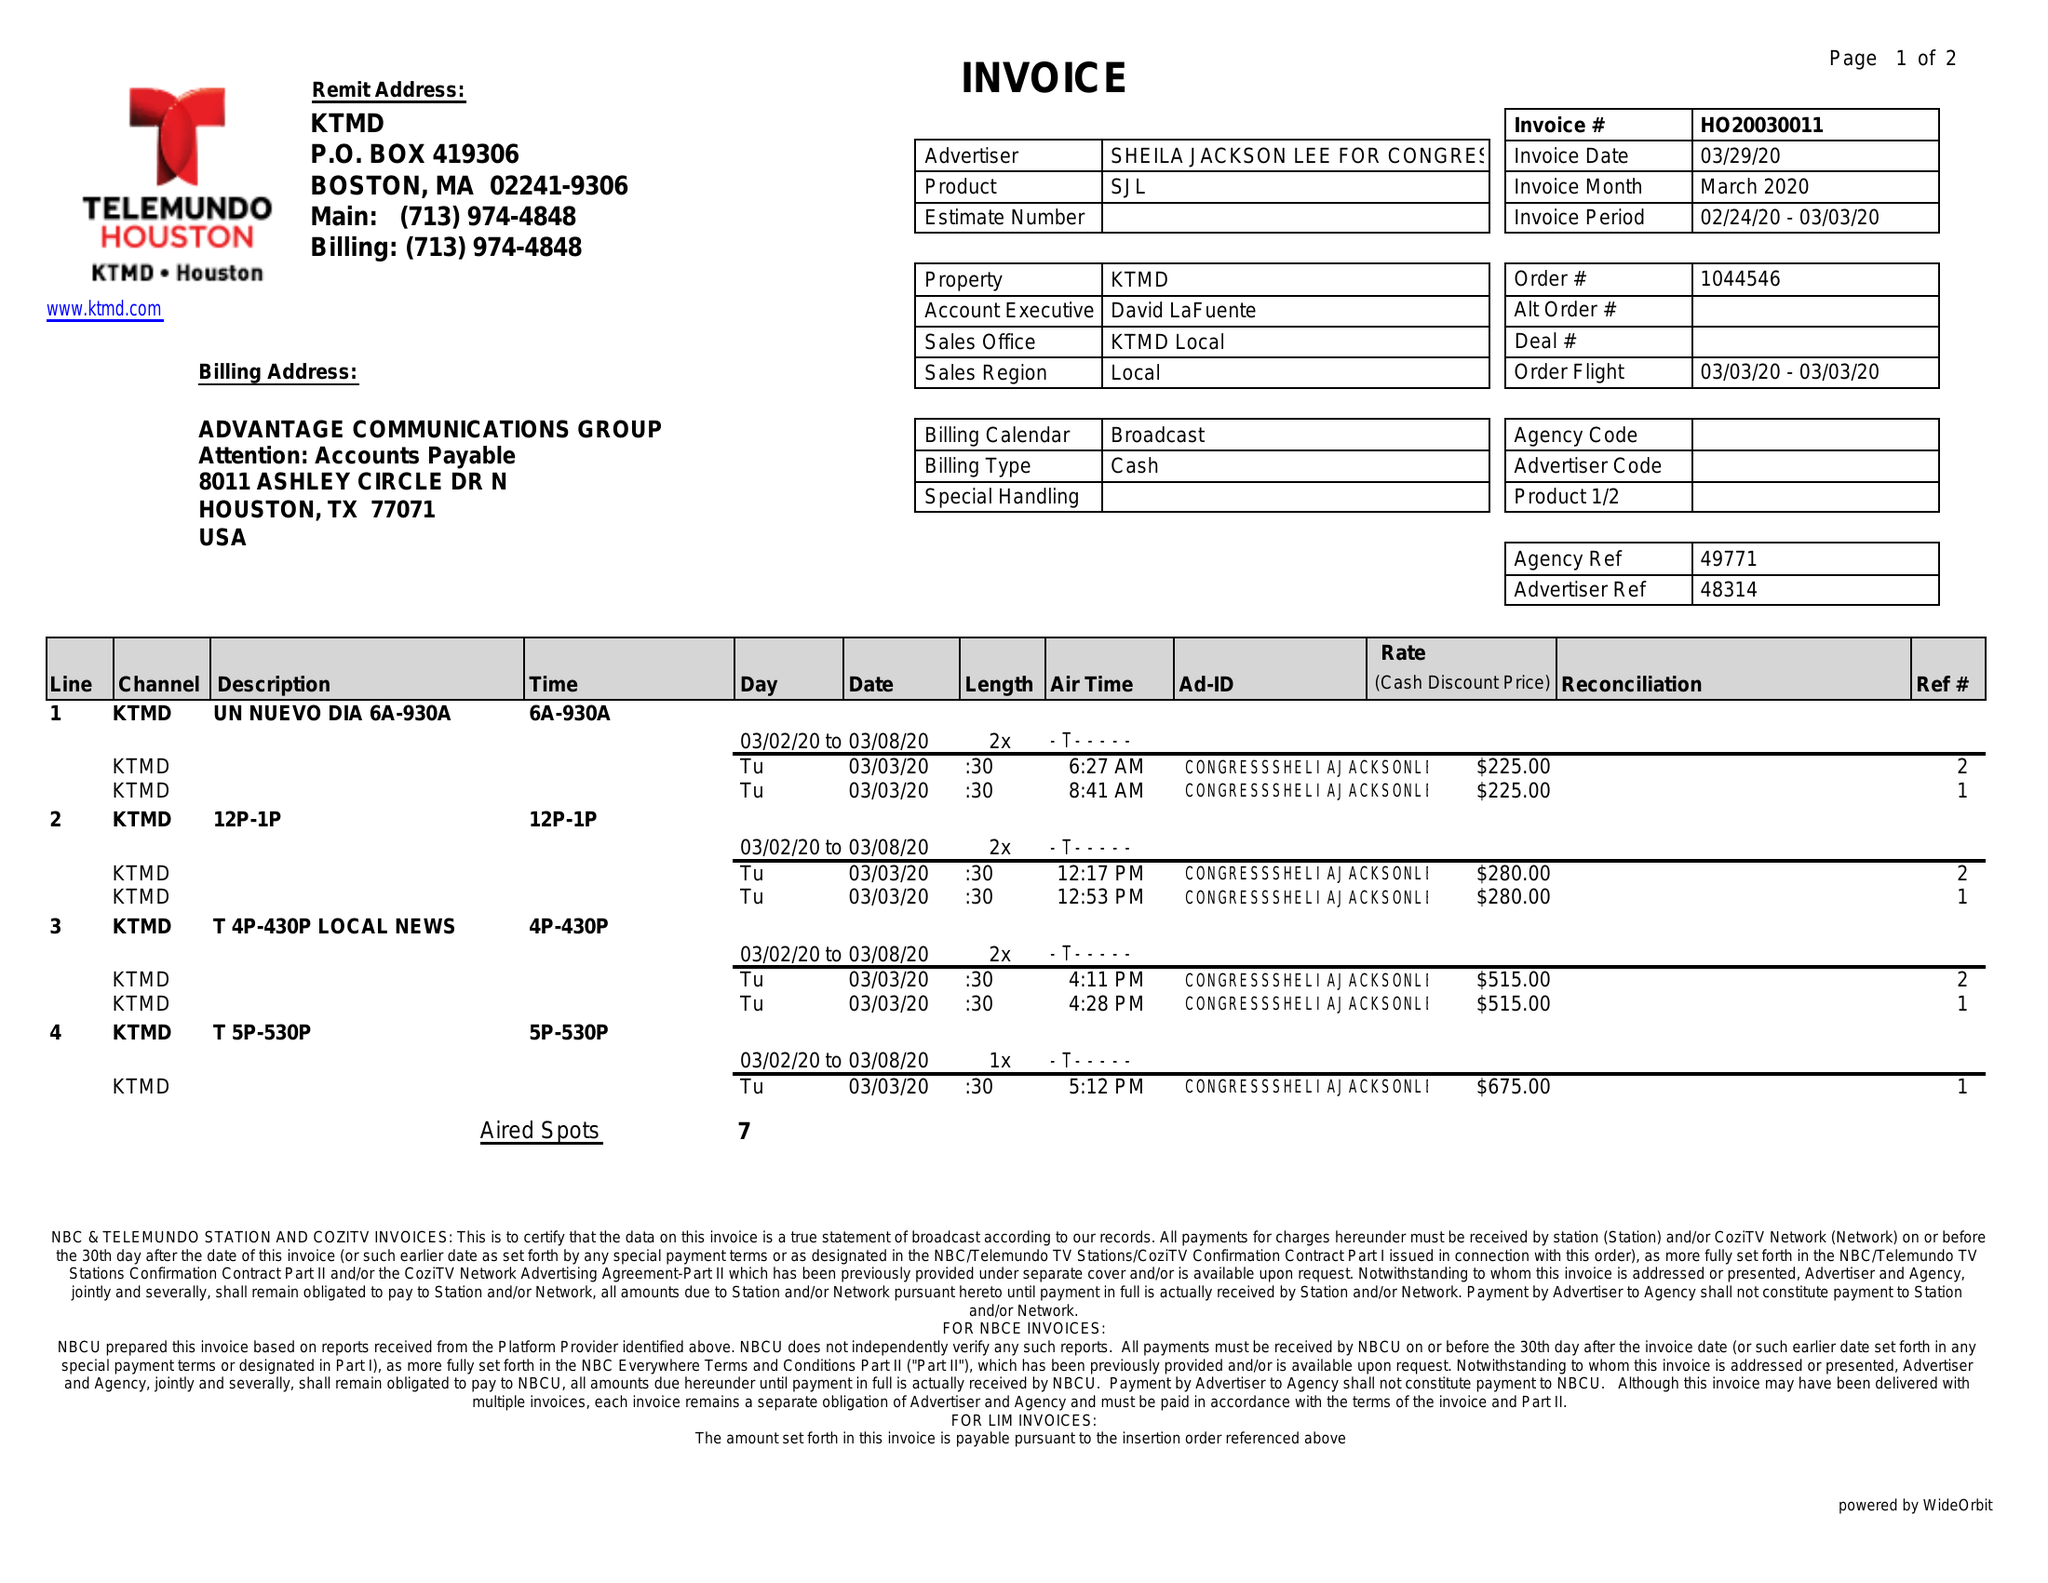What is the value for the flight_to?
Answer the question using a single word or phrase. 03/03/20 